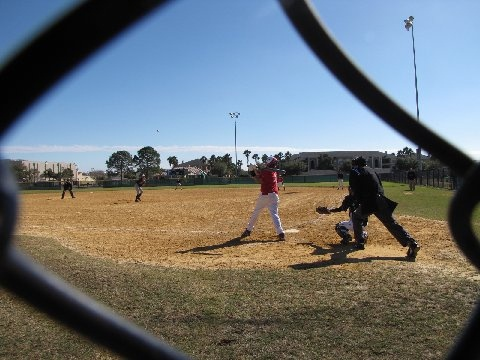Describe the objects in this image and their specific colors. I can see people in blue, black, gray, and tan tones, people in blue, gray, black, and maroon tones, people in blue, black, gray, and maroon tones, people in blue, black, gray, and maroon tones, and people in blue, black, gray, and darkgreen tones in this image. 